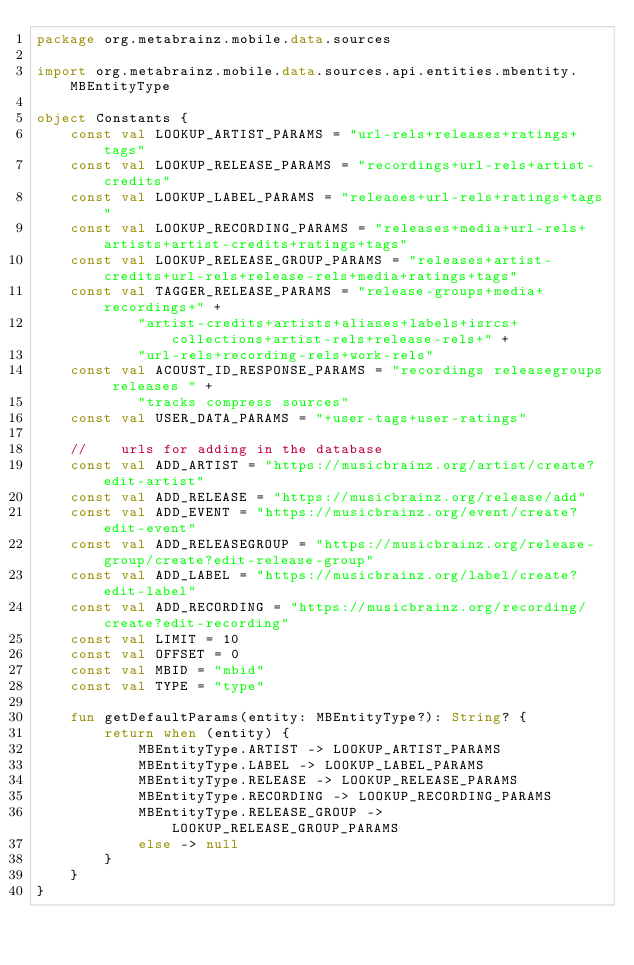<code> <loc_0><loc_0><loc_500><loc_500><_Kotlin_>package org.metabrainz.mobile.data.sources

import org.metabrainz.mobile.data.sources.api.entities.mbentity.MBEntityType

object Constants {
    const val LOOKUP_ARTIST_PARAMS = "url-rels+releases+ratings+tags"
    const val LOOKUP_RELEASE_PARAMS = "recordings+url-rels+artist-credits"
    const val LOOKUP_LABEL_PARAMS = "releases+url-rels+ratings+tags"
    const val LOOKUP_RECORDING_PARAMS = "releases+media+url-rels+artists+artist-credits+ratings+tags"
    const val LOOKUP_RELEASE_GROUP_PARAMS = "releases+artist-credits+url-rels+release-rels+media+ratings+tags"
    const val TAGGER_RELEASE_PARAMS = "release-groups+media+recordings+" +
            "artist-credits+artists+aliases+labels+isrcs+collections+artist-rels+release-rels+" +
            "url-rels+recording-rels+work-rels"
    const val ACOUST_ID_RESPONSE_PARAMS = "recordings releasegroups releases " +
            "tracks compress sources"
    const val USER_DATA_PARAMS = "+user-tags+user-ratings"

    //    urls for adding in the database
    const val ADD_ARTIST = "https://musicbrainz.org/artist/create?edit-artist"
    const val ADD_RELEASE = "https://musicbrainz.org/release/add"
    const val ADD_EVENT = "https://musicbrainz.org/event/create?edit-event"
    const val ADD_RELEASEGROUP = "https://musicbrainz.org/release-group/create?edit-release-group"
    const val ADD_LABEL = "https://musicbrainz.org/label/create?edit-label"
    const val ADD_RECORDING = "https://musicbrainz.org/recording/create?edit-recording"
    const val LIMIT = 10
    const val OFFSET = 0
    const val MBID = "mbid"
    const val TYPE = "type"

    fun getDefaultParams(entity: MBEntityType?): String? {
        return when (entity) {
            MBEntityType.ARTIST -> LOOKUP_ARTIST_PARAMS
            MBEntityType.LABEL -> LOOKUP_LABEL_PARAMS
            MBEntityType.RELEASE -> LOOKUP_RELEASE_PARAMS
            MBEntityType.RECORDING -> LOOKUP_RECORDING_PARAMS
            MBEntityType.RELEASE_GROUP -> LOOKUP_RELEASE_GROUP_PARAMS
            else -> null
        }
    }
}</code> 